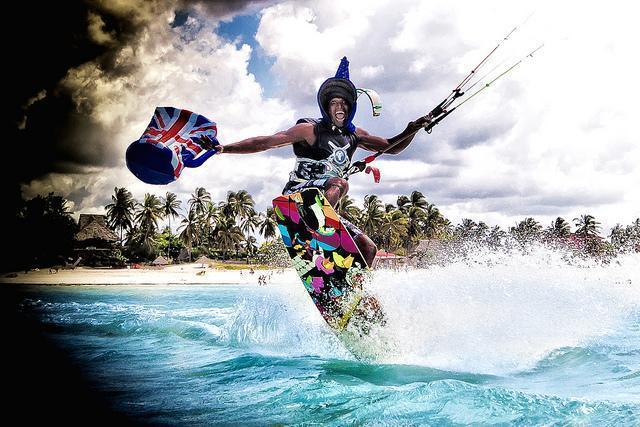How many kites are there?
Give a very brief answer. 0. 